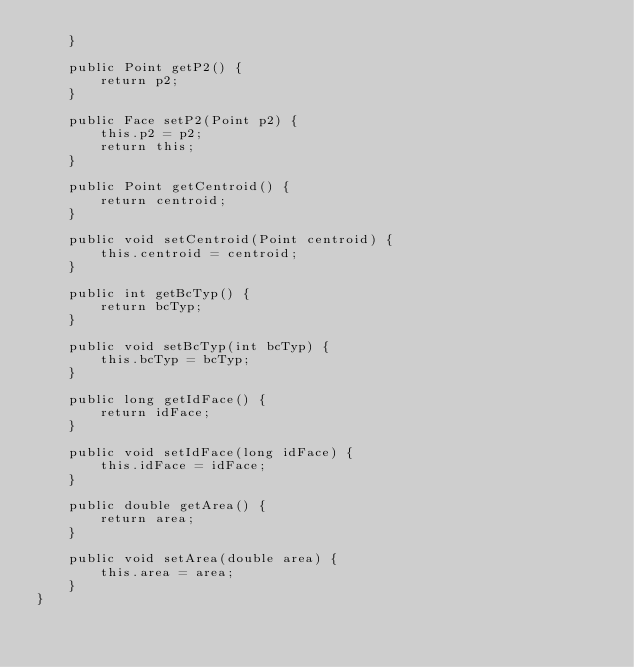Convert code to text. <code><loc_0><loc_0><loc_500><loc_500><_Java_>    }

    public Point getP2() {
        return p2;
    }

    public Face setP2(Point p2) {
        this.p2 = p2;
        return this;
    }

    public Point getCentroid() {
        return centroid;
    }

    public void setCentroid(Point centroid) {
        this.centroid = centroid;
    }

    public int getBcTyp() {
        return bcTyp;
    }

    public void setBcTyp(int bcTyp) {
        this.bcTyp = bcTyp;
    }

    public long getIdFace() {
        return idFace;
    }

    public void setIdFace(long idFace) {
        this.idFace = idFace;
    }

    public double getArea() {
        return area;
    }

    public void setArea(double area) {
        this.area = area;
    }
}
</code> 